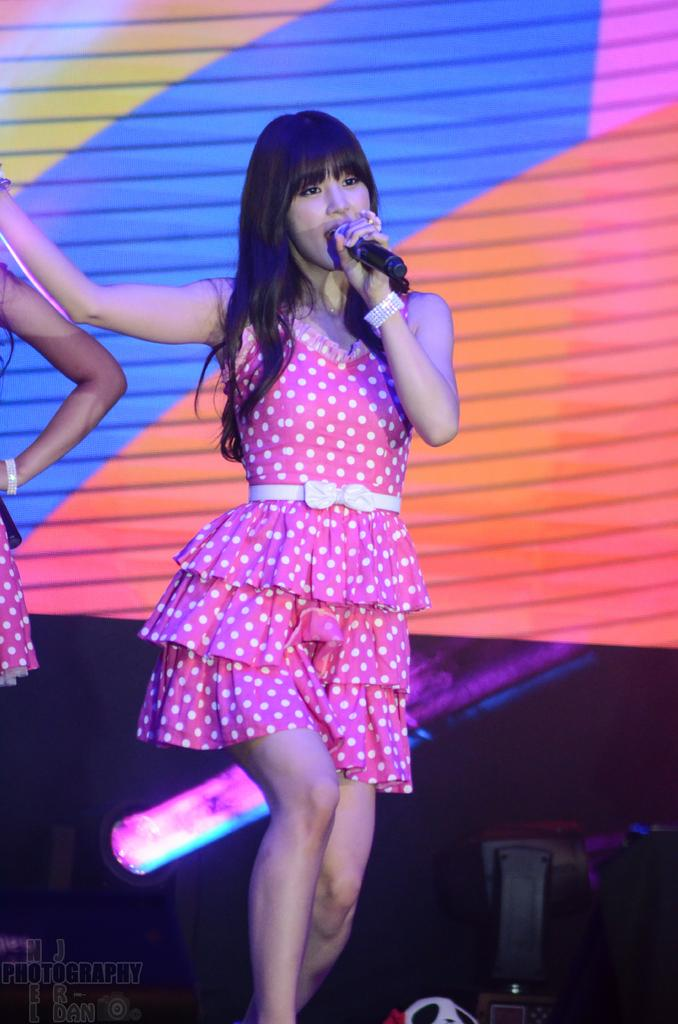Who is the main subject in the image? There is a woman in the image. What is the woman wearing? The woman is wearing a pink skirt. What object is the woman holding in the image? The woman is holding a microphone. What activity is the woman engaged in? The woman is singing a song. Is the woman controlling a baseball game in the image? No, there is no indication of a baseball game or any control over one in the image. 